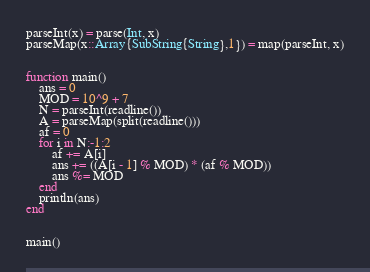<code> <loc_0><loc_0><loc_500><loc_500><_Julia_>parseInt(x) = parse(Int, x)
parseMap(x::Array{SubString{String},1}) = map(parseInt, x)


function main()
    ans = 0
    MOD = 10^9 + 7
    N = parseInt(readline())
    A = parseMap(split(readline()))
    af = 0
    for i in N:-1:2
        af += A[i]
        ans += ((A[i - 1] % MOD) * (af % MOD)) 
        ans %= MOD
    end
    println(ans)
end


main()
</code> 